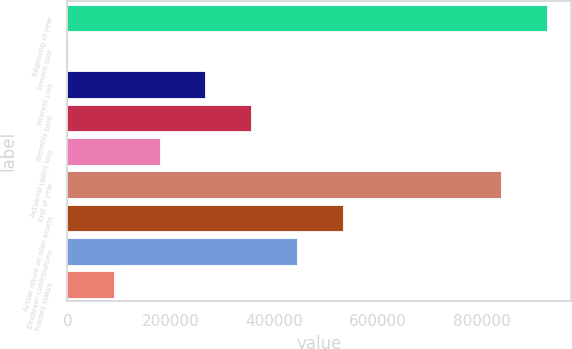Convert chart. <chart><loc_0><loc_0><loc_500><loc_500><bar_chart><fcel>Beginning of year<fcel>Service cost<fcel>Interest cost<fcel>Benefits paid<fcel>Actuarial (gain) loss<fcel>End of year<fcel>Actual return on plan assets<fcel>Employer contributions<fcel>Funded status<nl><fcel>925825<fcel>1445<fcel>266671<fcel>355079<fcel>178262<fcel>837416<fcel>531897<fcel>443488<fcel>89853.6<nl></chart> 